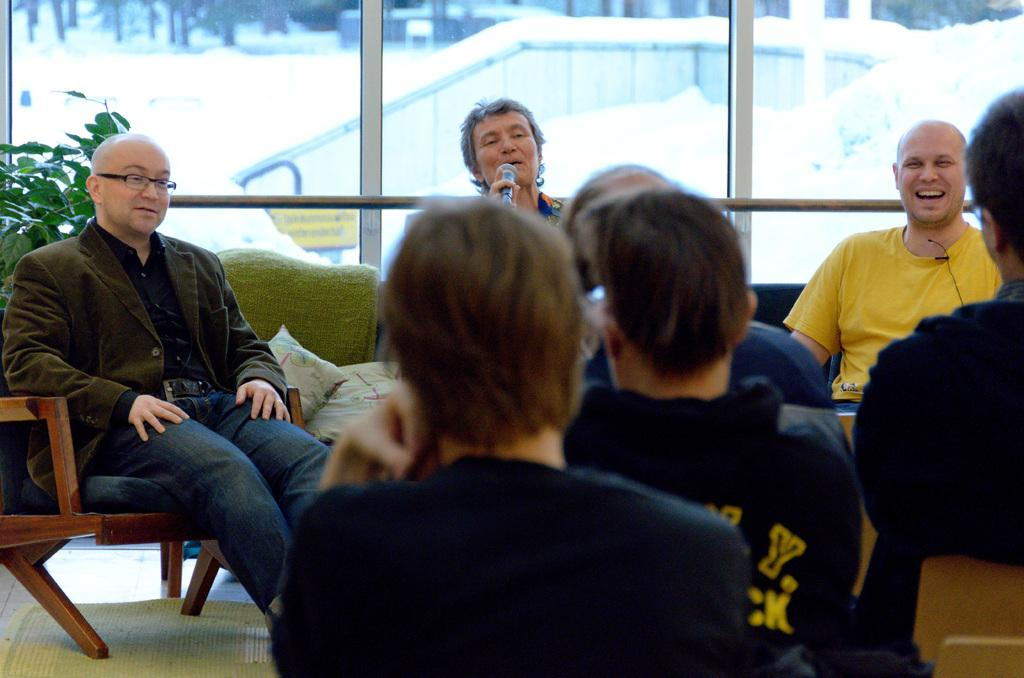What are the people in the image doing? The people in the image are sitting on a sofa. What is the woman with the microphone doing? The woman is holding a microphone in her hand. Who is the woman with the microphone addressing or speaking to? The people sitting in front of the woman with the microphone. Can you see any receipts on the sofa in the image? There is no mention of a receipt in the image, so it cannot be determined if one is present. 